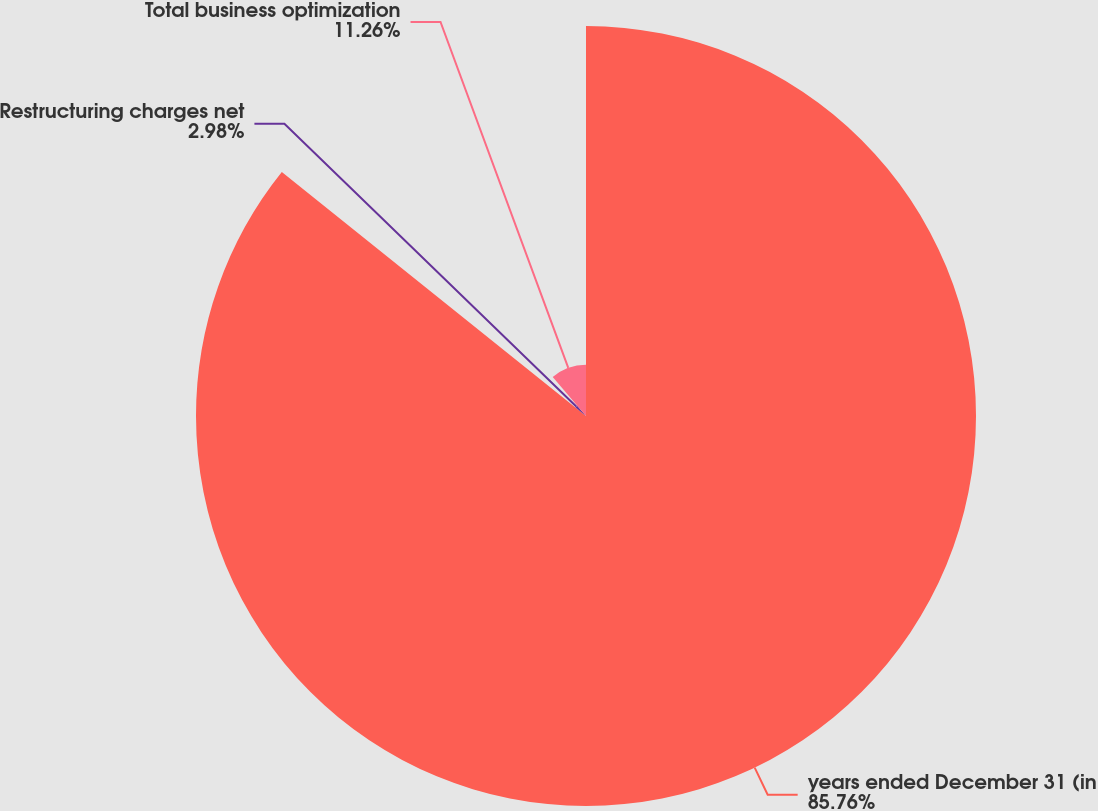<chart> <loc_0><loc_0><loc_500><loc_500><pie_chart><fcel>years ended December 31 (in<fcel>Restructuring charges net<fcel>Total business optimization<nl><fcel>85.77%<fcel>2.98%<fcel>11.26%<nl></chart> 